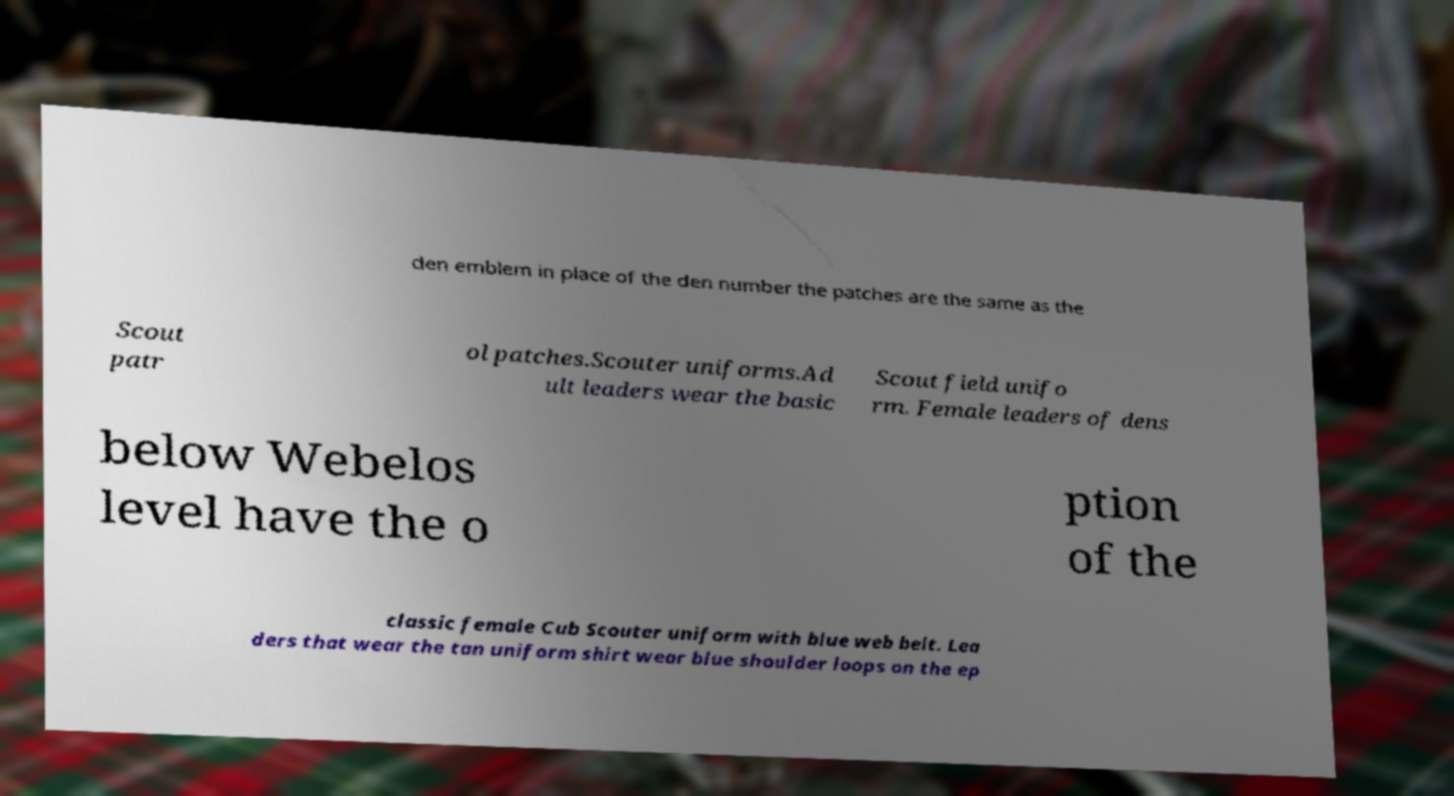Can you accurately transcribe the text from the provided image for me? den emblem in place of the den number the patches are the same as the Scout patr ol patches.Scouter uniforms.Ad ult leaders wear the basic Scout field unifo rm. Female leaders of dens below Webelos level have the o ption of the classic female Cub Scouter uniform with blue web belt. Lea ders that wear the tan uniform shirt wear blue shoulder loops on the ep 